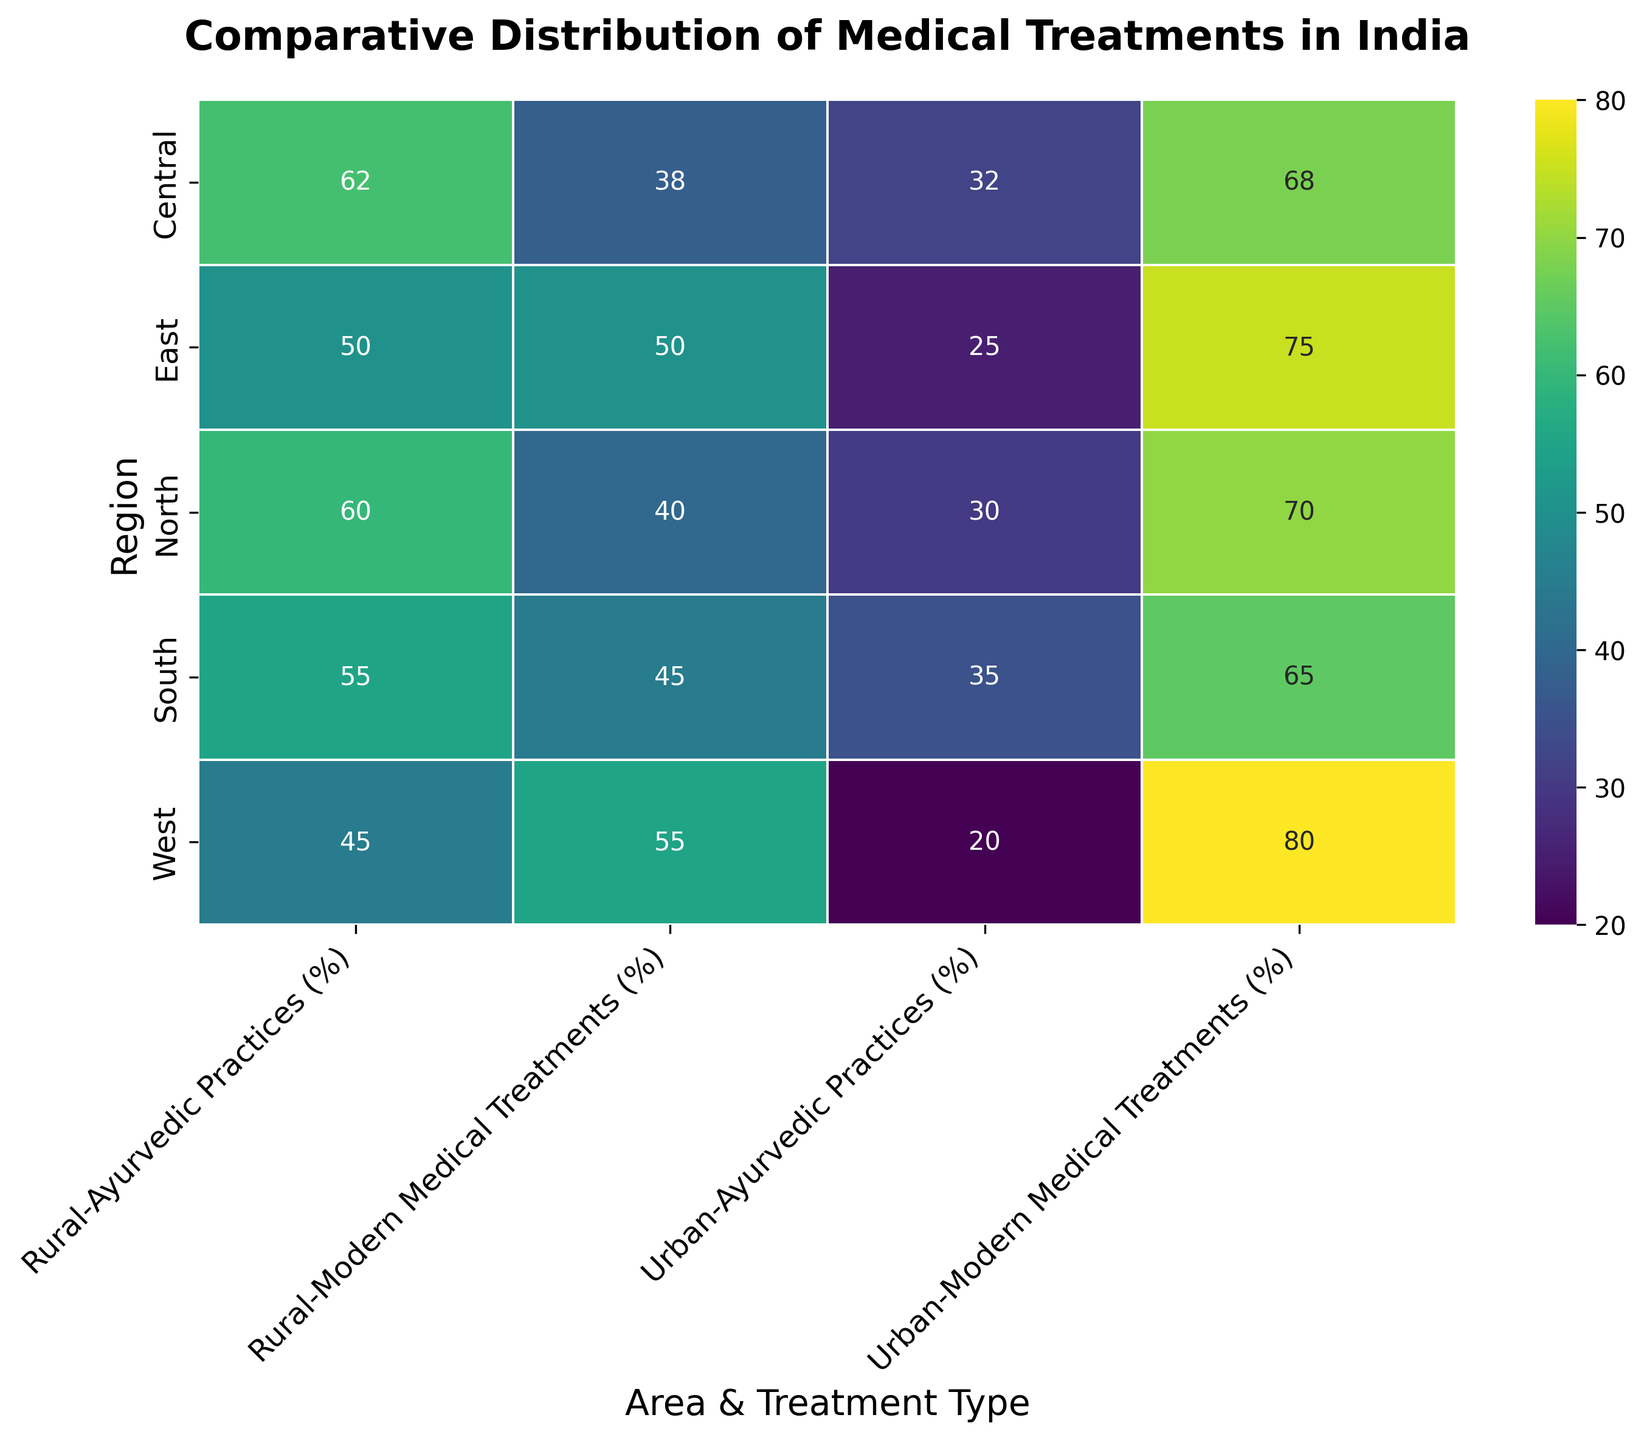What is the percentage difference of Ayurvedic Practices between urban and rural Northern regions? To find the percentage difference, subtract the percentage of Ayurvedic Practices in urban North from rural North. Urban North has 30%, and rural North has 60%. The difference is 60% - 30% = 30%.
Answer: 30% Which region has a higher percentage of modern medical treatments in rural areas? Compare the percentages of modern medical treatments in rural North, South, East, West, and Central. Rural West has 55%, the highest among rural areas.
Answer: West Which visual attribute indicates stronger reliance on Ayurvedic Practices in rural regions compared to urban areas? Observing the heatmap, we notice that darker green colors, which represent higher percentages of Ayurvedic Practices, are more prevalent in rural regions compared to urban regions.
Answer: Darker green in rural areas How does the percentage of modern medical treatments in Urban East compare to Urban South? Urban East has 75% and Urban South has 65% for modern medical treatments. Urban East has a higher percentage by 10% (75% - 65%).
Answer: Urban East by 10% What is the combined percentage of Ayurvedic Practices in both Urban West and Rural Central regions? Add the Ayurvedic Practices percentages from Urban West (20%) and Rural Central (62%). The combined percentage is 20% + 62% = 82%.
Answer: 82% Which region shows the smallest difference between urban and rural areas in terms of modern medical treatments? Calculate the difference in modern medical treatments for each region. North: 70% - 40% = 30%, South: 65% - 45% = 20%, East: 75% - 50% = 25%, West: 80% - 55% = 25%, Central: 68% - 38% = 30%. The South has the smallest difference of 20%.
Answer: South Is there any region where the percentage of modern medical treatments in rural areas exceeds 50%? Check the percentages for all rural regions. Rural West has 55%, which is the only region where it exceeds 50%.
Answer: Yes, West What is the average percentage of modern medical treatments in urban regions? Sum the percentages of modern medical treatments in Urban regions (70% + 65% + 75% + 80% + 68%) and divide by 5. The sum is 358%, and the average is 358% / 5 = 71.6%.
Answer: 71.6% What is the total percentage of Ayurvedic Practices in the Central region (urban and rural combined)? Add the percentages of Ayurvedic Practices in Urban Central (32%) and Rural Central (62%). The total percentage is 32% + 62% = 94%.
Answer: 94% Which urban region has the lowest percentage of Ayurvedic Practices? Compare the percentages of Ayurvedic Practices in urban regions: North (30%), South (35%), East (25%), West (20%), Central (32%). Urban West has the lowest at 20%.
Answer: West 